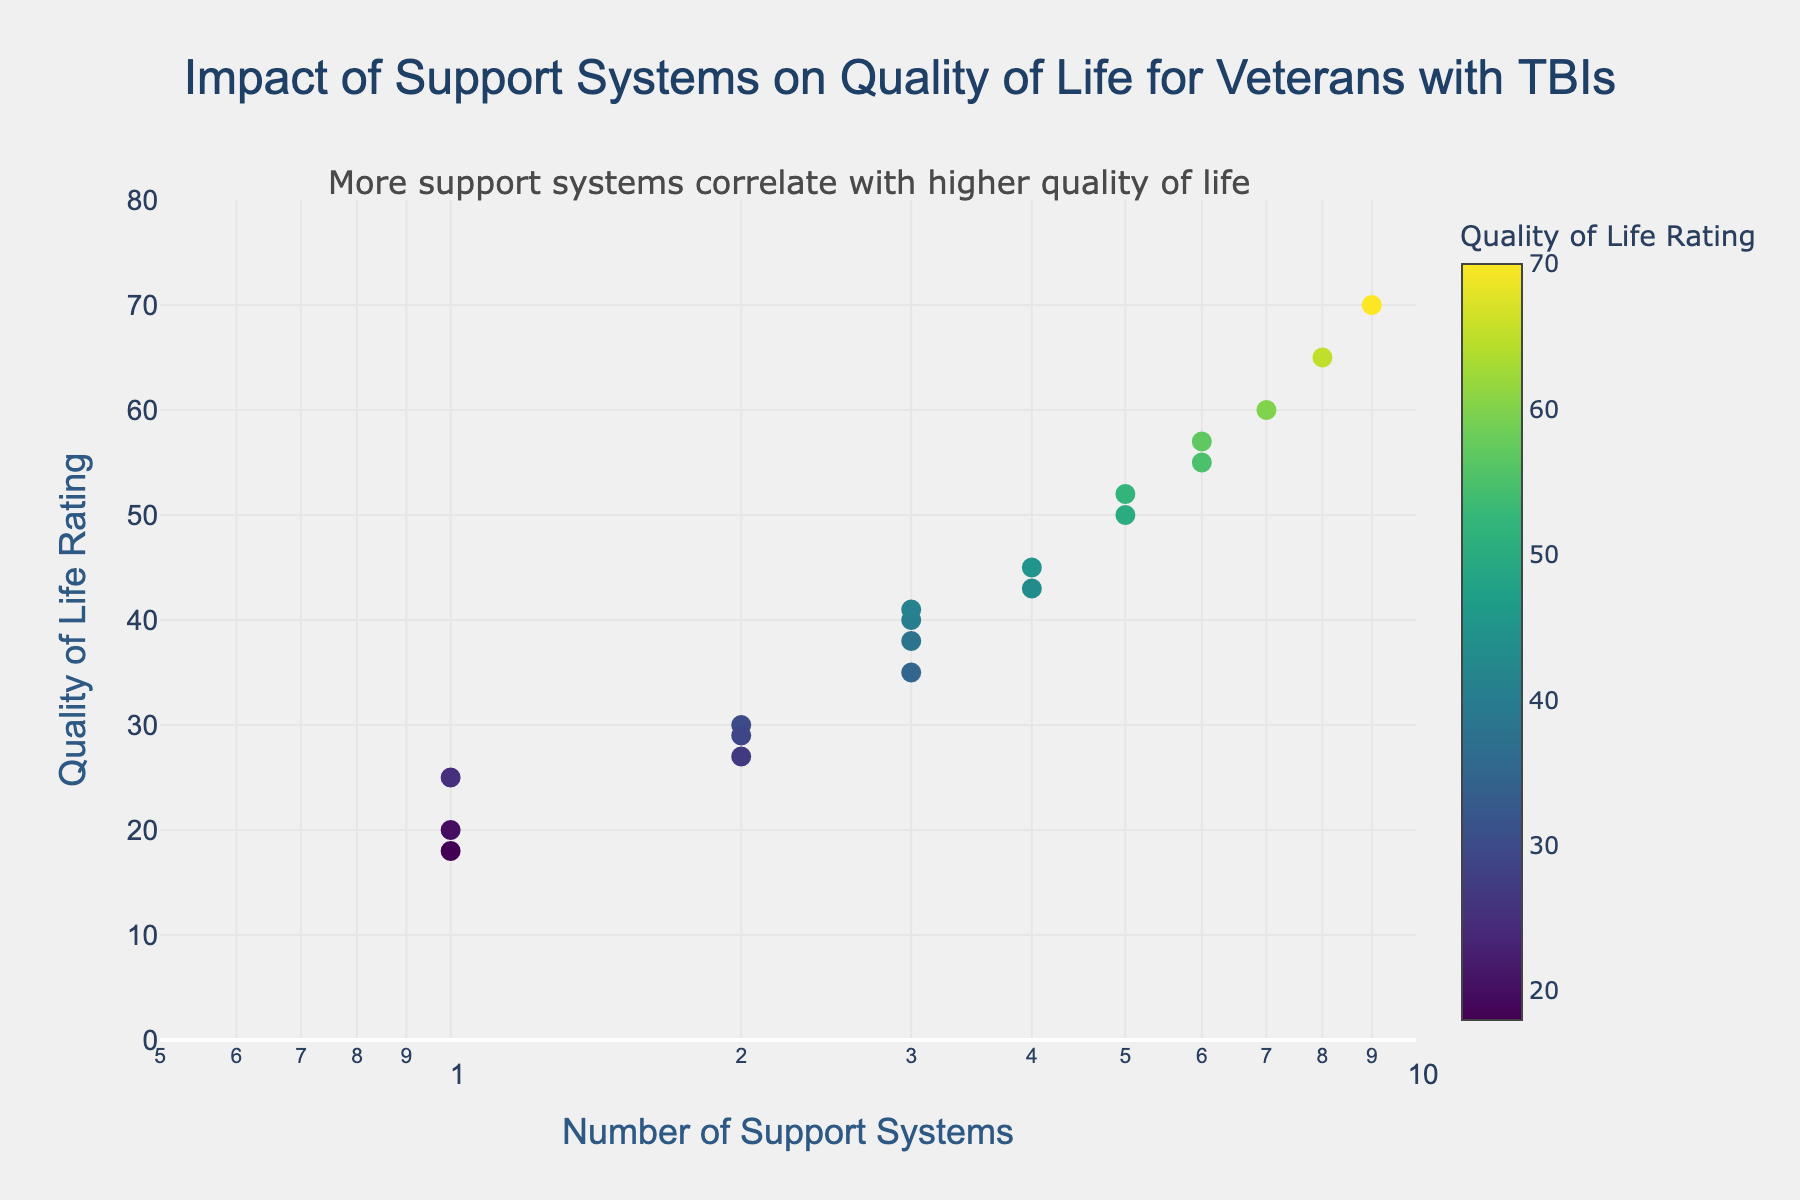How many data points are shown in the figure? By counting each marker in the scatter plot, we can identify the total number of data points.
Answer: 19 What is the title of the figure? Look at the text at the top of the figure to find the title.
Answer: "Impact of Support Systems on Quality of Life for Veterans with TBIs" What axis uses a logarithmic scale? Look for the axis that has a log scale indicator or a range that suggests logarithmic scaling.
Answer: X-axis (Number of Support Systems) What's the color used for the marker with the highest Quality of Life Rating? Locate the marker with the highest y-value (70) and observe its color. Notice the color scale shown in the figure.
Answer: Vibrant green (based on Viridis color scale) Compare the Quality of Life Ratings for veterans with 2 and 5 support systems. Which has better ratings? Identify the y-values associated with x-values of 2 and 5, then compare them. Veterans with 2 support systems have y-values around 27, 29, 30 while those with 5 support systems have y-values around 50 and 52.
Answer: 5 support systems What is the median Quality of Life Rating for veterans with 3 support systems? Identify and list the Quality of Life Ratings for x=3 (35, 38, 40, 41), then find the median value.
Answer: 38.5 Is there a visible trend between the number of support systems and Quality of Life Rating? Observe the overall pattern formed by the scatter plot points. The trend indicates that as the number of support systems increases, the Quality of Life Rating generally increases as well.
Answer: Yes, positive trend For veterans with 6 support systems, what is the range of Quality of Life Ratings? Identify the y-values associated with x=6 (55, 57) and calculate the range (subtract the smallest value from the largest).
Answer: 2 Which data point has the lowest Quality of Life Rating and how many support systems does it correspond to? Locate the marker with the lowest y-value (18) and read its corresponding x-value.
Answer: 1 support system 